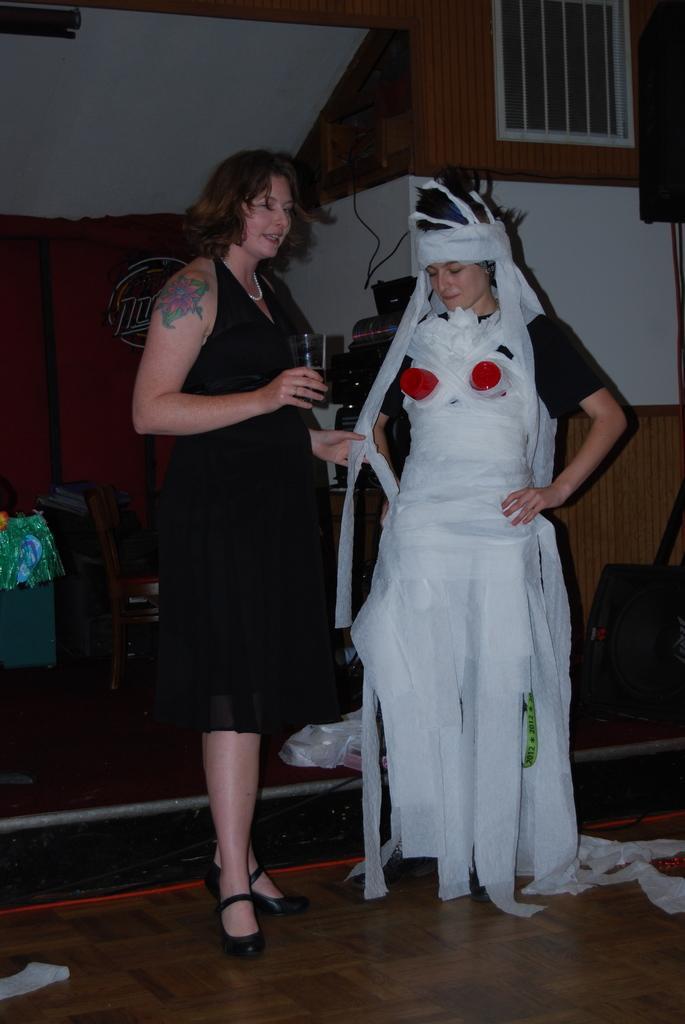Please provide a concise description of this image. In this picture we can observe two women. One of the women is wearing white color dress and the other is wearing black color dress. Both of them are standing on the floor. In the background we can observe a wall. 